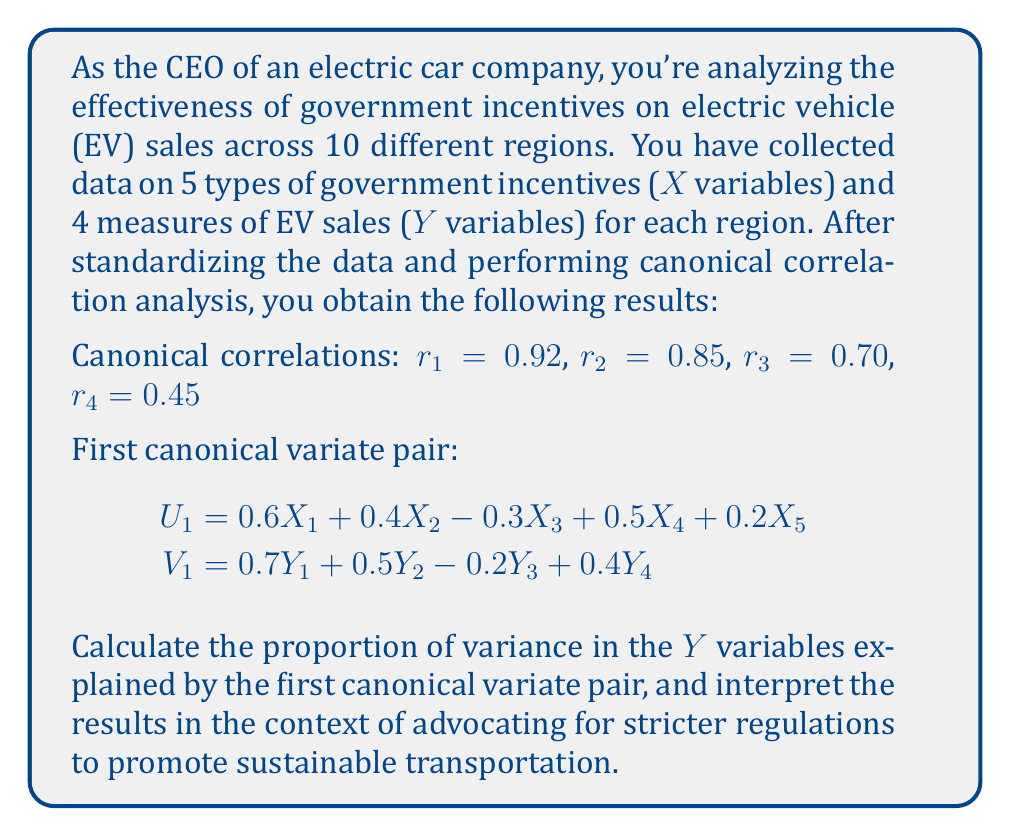Show me your answer to this math problem. To solve this problem, we'll follow these steps:

1) The proportion of variance explained by the first canonical variate pair is calculated using the square of the first canonical correlation ($r_1^2$) multiplied by the average of the squared loadings of the Y variables in the first canonical variate.

2) Calculate $r_1^2$:
   $r_1^2 = 0.92^2 = 0.8464$

3) Calculate the average of the squared loadings for $V_1$:
   $\text{Avg}(\text{squared loadings}) = \frac{0.7^2 + 0.5^2 + (-0.2)^2 + 0.4^2}{4} = \frac{0.49 + 0.25 + 0.04 + 0.16}{4} = \frac{0.94}{4} = 0.235$

4) Calculate the proportion of variance explained:
   $\text{Proportion} = r_1^2 \times \text{Avg}(\text{squared loadings}) = 0.8464 \times 0.235 = 0.1989$

5) Interpret the results:
   The first canonical variate pair explains approximately 19.89% of the variance in the EV sales measures. This indicates a strong relationship between government incentives and EV sales, supporting the argument for stricter regulations to promote sustainable transportation.

   The high canonical correlation ($r_1 = 0.92$) suggests that there is a strong linear relationship between the optimal linear combinations of government incentives and EV sales measures. This provides evidence that well-designed incentives can significantly impact EV adoption across different regions.

   As a CEO advocating for stricter regulations, you can use this result to argue that government policies have a substantial influence on EV sales. The analysis shows that carefully crafted incentives can explain a significant portion of the variation in EV adoption, supporting the case for more comprehensive and stringent regulations to accelerate the transition to sustainable transportation.
Answer: 19.89% of variance explained, indicating strong influence of government incentives on EV sales. 